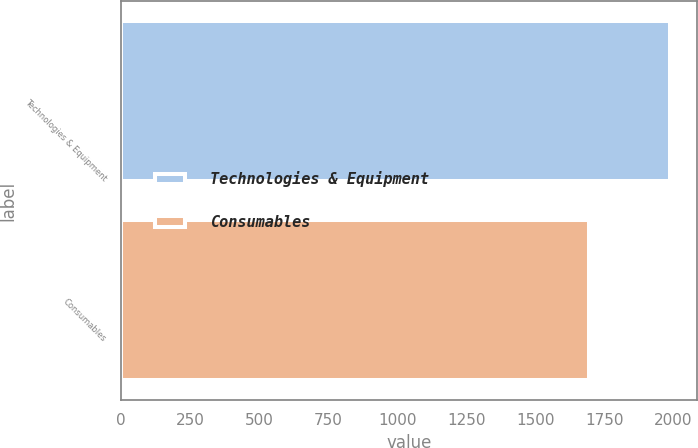Convert chart to OTSL. <chart><loc_0><loc_0><loc_500><loc_500><bar_chart><fcel>Technologies & Equipment<fcel>Consumables<nl><fcel>1986.4<fcel>1694.6<nl></chart> 